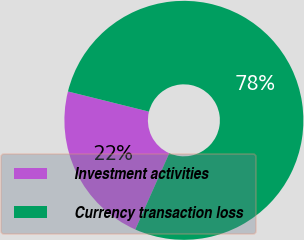Convert chart to OTSL. <chart><loc_0><loc_0><loc_500><loc_500><pie_chart><fcel>Investment activities<fcel>Currency transaction loss<nl><fcel>22.22%<fcel>77.78%<nl></chart> 